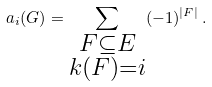<formula> <loc_0><loc_0><loc_500><loc_500>a _ { i } ( G ) = \sum _ { \substack { F \subseteq E \\ k ( F ) = i } } ( - 1 ) ^ { | F | } \, .</formula> 